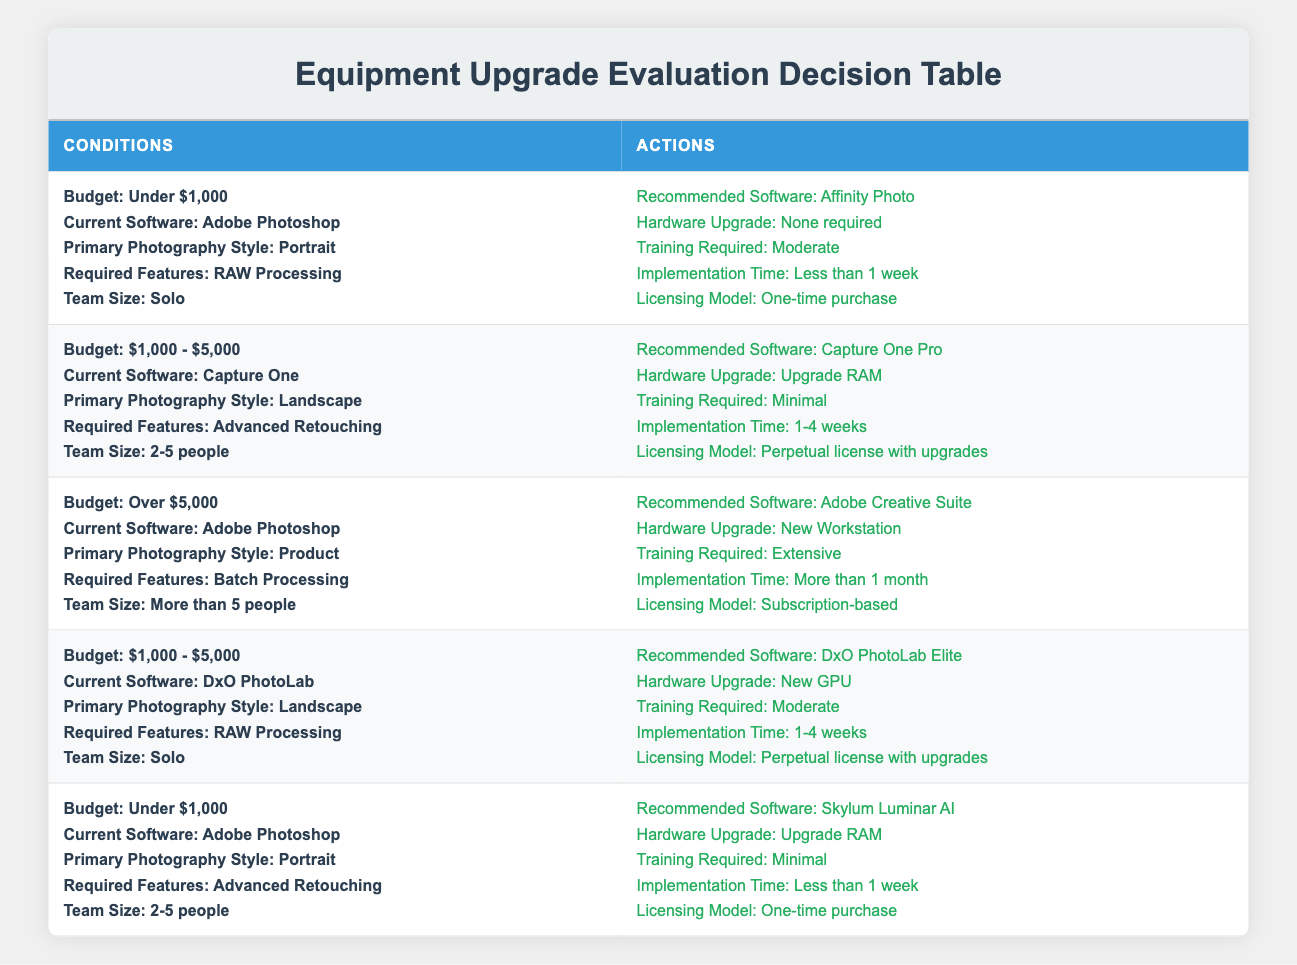What recommended software do you get for a budget under $1,000 with Adobe Photoshop? In the first rule of the table, the conditions are a budget under $1,000, current software Adobe Photoshop, primary style Portrait, required feature RAW Processing, and team size Solo. The action specified for these conditions is Affinity Photo.
Answer: Affinity Photo Is extensive training required if you choose Adobe Creative Suite for a budget over $5,000? In the third rule, with conditions being a budget over $5,000 and current software Adobe Photoshop, extensive training is specified as required.
Answer: Yes What hardware upgrade is suggested when using DxO PhotoLab for landscape photography with a budget between $1,000 and $5,000? The fourth rule shows that the conditions include a budget of $1,000 - $5,000 with current software being DxO PhotoLab, primary style Landscape, required feature RAW Processing, and team size Solo. The suggested hardware upgrade is a new GPU.
Answer: New GPU How many recommended software options require minimal training? Evaluating the table, there are two rules that specify minimal training: the second rule with Capture One Pro and the first rule with Skylum Luminar AI. This sums up to 2 software options that require minimal training.
Answer: 2 If I have a team of 2-5 people and a budget of $1,000 - $5,000, which recommended software is appropriate? The second rule fits these conditions: a budget of $1,000 - $5,000, current software being Capture One, primary style Landscape, required feature Advanced Retouching, and team size 2-5 people, which leads to the recommended software being Capture One Pro.
Answer: Capture One Pro Is a new workstation required for any of the conditions related to a product photography style? The third rule indicates that for product photography with a budget over $5,000 using Adobe Photoshop, a new workstation is required. Therefore, the answer is yes.
Answer: Yes What is the implementation time for the recommended software when the budget is under $1,000 and the current software is Adobe Photoshop for portrait? The first rule shows that with these conditions, the implementation time is stated as "Less than 1 week."
Answer: Less than 1 week What is the average budget category represented in the table? The budget categories represented are Under $1,000, $1,000 - $5,000, and Over $5,000. Since there are three categories, we cannot compute an average numerically, but conceptually, the middle category is $1,000 - $5,000, making it the central tendency.
Answer: $1,000 - $5,000 Does Skylum Luminar AI require an extensive amount of training? According to the fifth rule where Skylum Luminar AI is mentioned, it specifies minimal training required, so the answer is no.
Answer: No 